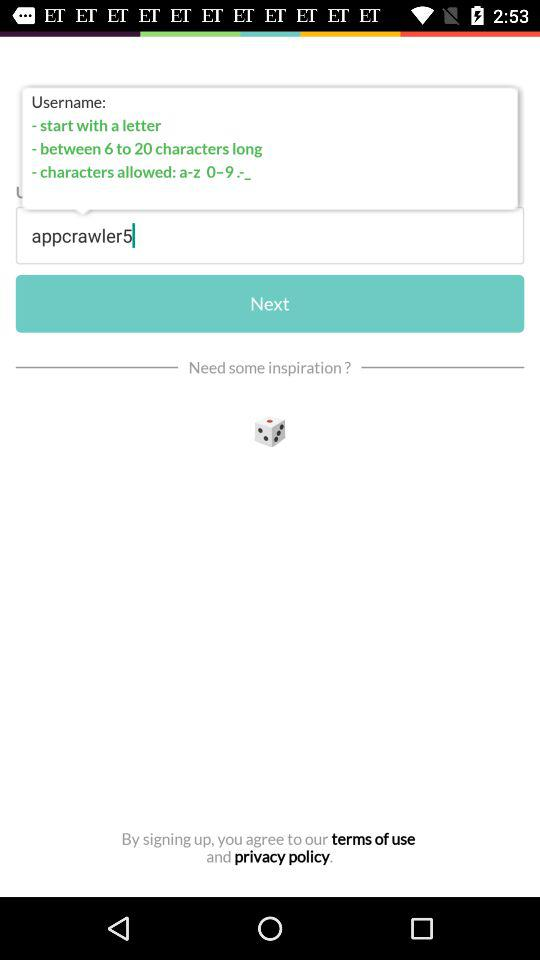Which tab is selected?
When the provided information is insufficient, respond with <no answer>. <no answer> 